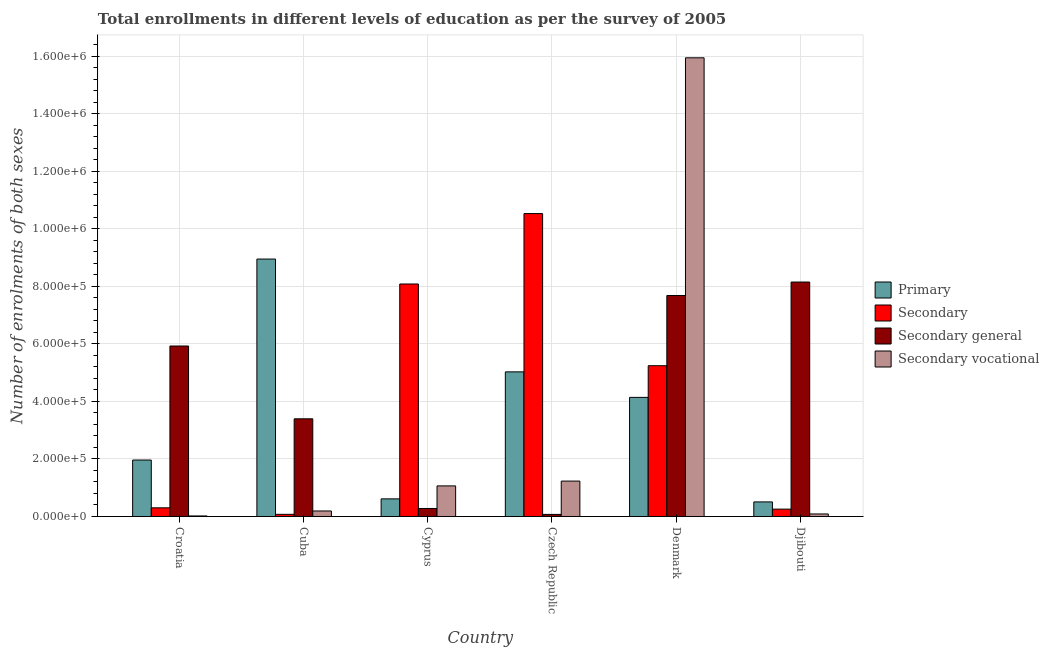How many groups of bars are there?
Your answer should be compact. 6. Are the number of bars per tick equal to the number of legend labels?
Your response must be concise. Yes. Are the number of bars on each tick of the X-axis equal?
Offer a very short reply. Yes. How many bars are there on the 2nd tick from the left?
Your response must be concise. 4. What is the number of enrolments in secondary general education in Croatia?
Provide a short and direct response. 5.93e+05. Across all countries, what is the maximum number of enrolments in secondary general education?
Your response must be concise. 8.15e+05. Across all countries, what is the minimum number of enrolments in secondary education?
Make the answer very short. 7476. In which country was the number of enrolments in secondary general education maximum?
Your answer should be very brief. Djibouti. In which country was the number of enrolments in secondary education minimum?
Make the answer very short. Cuba. What is the total number of enrolments in secondary vocational education in the graph?
Provide a succinct answer. 1.85e+06. What is the difference between the number of enrolments in secondary education in Cuba and that in Djibouti?
Your answer should be compact. -1.81e+04. What is the difference between the number of enrolments in secondary vocational education in Cuba and the number of enrolments in primary education in Cyprus?
Provide a succinct answer. -4.21e+04. What is the average number of enrolments in secondary general education per country?
Give a very brief answer. 4.25e+05. What is the difference between the number of enrolments in secondary vocational education and number of enrolments in secondary education in Denmark?
Offer a very short reply. 1.07e+06. In how many countries, is the number of enrolments in secondary general education greater than 1360000 ?
Give a very brief answer. 0. What is the ratio of the number of enrolments in secondary vocational education in Croatia to that in Cuba?
Provide a short and direct response. 0.1. Is the difference between the number of enrolments in secondary education in Cuba and Denmark greater than the difference between the number of enrolments in secondary general education in Cuba and Denmark?
Your response must be concise. No. What is the difference between the highest and the second highest number of enrolments in secondary general education?
Your answer should be very brief. 4.68e+04. What is the difference between the highest and the lowest number of enrolments in secondary vocational education?
Ensure brevity in your answer.  1.59e+06. What does the 3rd bar from the left in Cyprus represents?
Give a very brief answer. Secondary general. What does the 3rd bar from the right in Denmark represents?
Provide a succinct answer. Secondary. Is it the case that in every country, the sum of the number of enrolments in primary education and number of enrolments in secondary education is greater than the number of enrolments in secondary general education?
Provide a short and direct response. No. How many bars are there?
Ensure brevity in your answer.  24. How many countries are there in the graph?
Give a very brief answer. 6. Are the values on the major ticks of Y-axis written in scientific E-notation?
Provide a short and direct response. Yes. How many legend labels are there?
Provide a short and direct response. 4. What is the title of the graph?
Make the answer very short. Total enrollments in different levels of education as per the survey of 2005. Does "Others" appear as one of the legend labels in the graph?
Give a very brief answer. No. What is the label or title of the Y-axis?
Offer a very short reply. Number of enrolments of both sexes. What is the Number of enrolments of both sexes of Primary in Croatia?
Make the answer very short. 1.96e+05. What is the Number of enrolments of both sexes of Secondary in Croatia?
Your answer should be very brief. 3.01e+04. What is the Number of enrolments of both sexes of Secondary general in Croatia?
Your answer should be very brief. 5.93e+05. What is the Number of enrolments of both sexes in Secondary vocational in Croatia?
Make the answer very short. 1864. What is the Number of enrolments of both sexes in Primary in Cuba?
Give a very brief answer. 8.95e+05. What is the Number of enrolments of both sexes of Secondary in Cuba?
Provide a succinct answer. 7476. What is the Number of enrolments of both sexes in Secondary general in Cuba?
Your response must be concise. 3.40e+05. What is the Number of enrolments of both sexes of Secondary vocational in Cuba?
Your response must be concise. 1.92e+04. What is the Number of enrolments of both sexes in Primary in Cyprus?
Your response must be concise. 6.12e+04. What is the Number of enrolments of both sexes in Secondary in Cyprus?
Your answer should be compact. 8.08e+05. What is the Number of enrolments of both sexes in Secondary general in Cyprus?
Offer a very short reply. 2.78e+04. What is the Number of enrolments of both sexes in Secondary vocational in Cyprus?
Ensure brevity in your answer.  1.06e+05. What is the Number of enrolments of both sexes in Primary in Czech Republic?
Ensure brevity in your answer.  5.03e+05. What is the Number of enrolments of both sexes in Secondary in Czech Republic?
Your response must be concise. 1.05e+06. What is the Number of enrolments of both sexes in Secondary general in Czech Republic?
Ensure brevity in your answer.  7218. What is the Number of enrolments of both sexes of Secondary vocational in Czech Republic?
Your answer should be very brief. 1.23e+05. What is the Number of enrolments of both sexes of Primary in Denmark?
Ensure brevity in your answer.  4.14e+05. What is the Number of enrolments of both sexes in Secondary in Denmark?
Ensure brevity in your answer.  5.24e+05. What is the Number of enrolments of both sexes in Secondary general in Denmark?
Your response must be concise. 7.68e+05. What is the Number of enrolments of both sexes of Secondary vocational in Denmark?
Keep it short and to the point. 1.59e+06. What is the Number of enrolments of both sexes of Primary in Djibouti?
Keep it short and to the point. 5.07e+04. What is the Number of enrolments of both sexes of Secondary in Djibouti?
Provide a short and direct response. 2.55e+04. What is the Number of enrolments of both sexes in Secondary general in Djibouti?
Make the answer very short. 8.15e+05. What is the Number of enrolments of both sexes of Secondary vocational in Djibouti?
Keep it short and to the point. 8777. Across all countries, what is the maximum Number of enrolments of both sexes of Primary?
Your response must be concise. 8.95e+05. Across all countries, what is the maximum Number of enrolments of both sexes of Secondary?
Ensure brevity in your answer.  1.05e+06. Across all countries, what is the maximum Number of enrolments of both sexes of Secondary general?
Make the answer very short. 8.15e+05. Across all countries, what is the maximum Number of enrolments of both sexes of Secondary vocational?
Give a very brief answer. 1.59e+06. Across all countries, what is the minimum Number of enrolments of both sexes in Primary?
Offer a very short reply. 5.07e+04. Across all countries, what is the minimum Number of enrolments of both sexes of Secondary?
Keep it short and to the point. 7476. Across all countries, what is the minimum Number of enrolments of both sexes in Secondary general?
Your answer should be very brief. 7218. Across all countries, what is the minimum Number of enrolments of both sexes of Secondary vocational?
Your answer should be compact. 1864. What is the total Number of enrolments of both sexes in Primary in the graph?
Ensure brevity in your answer.  2.12e+06. What is the total Number of enrolments of both sexes in Secondary in the graph?
Your answer should be compact. 2.45e+06. What is the total Number of enrolments of both sexes in Secondary general in the graph?
Make the answer very short. 2.55e+06. What is the total Number of enrolments of both sexes in Secondary vocational in the graph?
Your answer should be very brief. 1.85e+06. What is the difference between the Number of enrolments of both sexes of Primary in Croatia and that in Cuba?
Keep it short and to the point. -6.99e+05. What is the difference between the Number of enrolments of both sexes of Secondary in Croatia and that in Cuba?
Your response must be concise. 2.27e+04. What is the difference between the Number of enrolments of both sexes in Secondary general in Croatia and that in Cuba?
Your response must be concise. 2.53e+05. What is the difference between the Number of enrolments of both sexes of Secondary vocational in Croatia and that in Cuba?
Provide a short and direct response. -1.73e+04. What is the difference between the Number of enrolments of both sexes in Primary in Croatia and that in Cyprus?
Your answer should be very brief. 1.35e+05. What is the difference between the Number of enrolments of both sexes in Secondary in Croatia and that in Cyprus?
Give a very brief answer. -7.78e+05. What is the difference between the Number of enrolments of both sexes of Secondary general in Croatia and that in Cyprus?
Ensure brevity in your answer.  5.65e+05. What is the difference between the Number of enrolments of both sexes in Secondary vocational in Croatia and that in Cyprus?
Give a very brief answer. -1.04e+05. What is the difference between the Number of enrolments of both sexes in Primary in Croatia and that in Czech Republic?
Offer a very short reply. -3.07e+05. What is the difference between the Number of enrolments of both sexes of Secondary in Croatia and that in Czech Republic?
Keep it short and to the point. -1.02e+06. What is the difference between the Number of enrolments of both sexes of Secondary general in Croatia and that in Czech Republic?
Your response must be concise. 5.85e+05. What is the difference between the Number of enrolments of both sexes of Secondary vocational in Croatia and that in Czech Republic?
Ensure brevity in your answer.  -1.21e+05. What is the difference between the Number of enrolments of both sexes in Primary in Croatia and that in Denmark?
Offer a very short reply. -2.18e+05. What is the difference between the Number of enrolments of both sexes of Secondary in Croatia and that in Denmark?
Your answer should be compact. -4.94e+05. What is the difference between the Number of enrolments of both sexes in Secondary general in Croatia and that in Denmark?
Ensure brevity in your answer.  -1.76e+05. What is the difference between the Number of enrolments of both sexes in Secondary vocational in Croatia and that in Denmark?
Provide a succinct answer. -1.59e+06. What is the difference between the Number of enrolments of both sexes in Primary in Croatia and that in Djibouti?
Make the answer very short. 1.46e+05. What is the difference between the Number of enrolments of both sexes of Secondary in Croatia and that in Djibouti?
Make the answer very short. 4598. What is the difference between the Number of enrolments of both sexes of Secondary general in Croatia and that in Djibouti?
Your response must be concise. -2.22e+05. What is the difference between the Number of enrolments of both sexes in Secondary vocational in Croatia and that in Djibouti?
Make the answer very short. -6913. What is the difference between the Number of enrolments of both sexes of Primary in Cuba and that in Cyprus?
Make the answer very short. 8.34e+05. What is the difference between the Number of enrolments of both sexes in Secondary in Cuba and that in Cyprus?
Offer a very short reply. -8.01e+05. What is the difference between the Number of enrolments of both sexes of Secondary general in Cuba and that in Cyprus?
Make the answer very short. 3.12e+05. What is the difference between the Number of enrolments of both sexes in Secondary vocational in Cuba and that in Cyprus?
Your answer should be compact. -8.72e+04. What is the difference between the Number of enrolments of both sexes of Primary in Cuba and that in Czech Republic?
Provide a short and direct response. 3.92e+05. What is the difference between the Number of enrolments of both sexes of Secondary in Cuba and that in Czech Republic?
Ensure brevity in your answer.  -1.05e+06. What is the difference between the Number of enrolments of both sexes of Secondary general in Cuba and that in Czech Republic?
Make the answer very short. 3.32e+05. What is the difference between the Number of enrolments of both sexes of Secondary vocational in Cuba and that in Czech Republic?
Offer a terse response. -1.04e+05. What is the difference between the Number of enrolments of both sexes in Primary in Cuba and that in Denmark?
Keep it short and to the point. 4.81e+05. What is the difference between the Number of enrolments of both sexes of Secondary in Cuba and that in Denmark?
Provide a short and direct response. -5.17e+05. What is the difference between the Number of enrolments of both sexes of Secondary general in Cuba and that in Denmark?
Your answer should be compact. -4.29e+05. What is the difference between the Number of enrolments of both sexes of Secondary vocational in Cuba and that in Denmark?
Your response must be concise. -1.58e+06. What is the difference between the Number of enrolments of both sexes in Primary in Cuba and that in Djibouti?
Your response must be concise. 8.44e+05. What is the difference between the Number of enrolments of both sexes of Secondary in Cuba and that in Djibouti?
Your answer should be compact. -1.81e+04. What is the difference between the Number of enrolments of both sexes in Secondary general in Cuba and that in Djibouti?
Offer a very short reply. -4.76e+05. What is the difference between the Number of enrolments of both sexes in Secondary vocational in Cuba and that in Djibouti?
Ensure brevity in your answer.  1.04e+04. What is the difference between the Number of enrolments of both sexes in Primary in Cyprus and that in Czech Republic?
Offer a very short reply. -4.42e+05. What is the difference between the Number of enrolments of both sexes in Secondary in Cyprus and that in Czech Republic?
Provide a short and direct response. -2.45e+05. What is the difference between the Number of enrolments of both sexes of Secondary general in Cyprus and that in Czech Republic?
Keep it short and to the point. 2.06e+04. What is the difference between the Number of enrolments of both sexes in Secondary vocational in Cyprus and that in Czech Republic?
Offer a terse response. -1.68e+04. What is the difference between the Number of enrolments of both sexes in Primary in Cyprus and that in Denmark?
Your answer should be compact. -3.53e+05. What is the difference between the Number of enrolments of both sexes of Secondary in Cyprus and that in Denmark?
Keep it short and to the point. 2.84e+05. What is the difference between the Number of enrolments of both sexes of Secondary general in Cyprus and that in Denmark?
Offer a very short reply. -7.41e+05. What is the difference between the Number of enrolments of both sexes of Secondary vocational in Cyprus and that in Denmark?
Keep it short and to the point. -1.49e+06. What is the difference between the Number of enrolments of both sexes in Primary in Cyprus and that in Djibouti?
Provide a short and direct response. 1.06e+04. What is the difference between the Number of enrolments of both sexes of Secondary in Cyprus and that in Djibouti?
Offer a very short reply. 7.83e+05. What is the difference between the Number of enrolments of both sexes in Secondary general in Cyprus and that in Djibouti?
Your response must be concise. -7.87e+05. What is the difference between the Number of enrolments of both sexes of Secondary vocational in Cyprus and that in Djibouti?
Provide a succinct answer. 9.76e+04. What is the difference between the Number of enrolments of both sexes in Primary in Czech Republic and that in Denmark?
Offer a terse response. 8.87e+04. What is the difference between the Number of enrolments of both sexes of Secondary in Czech Republic and that in Denmark?
Give a very brief answer. 5.29e+05. What is the difference between the Number of enrolments of both sexes in Secondary general in Czech Republic and that in Denmark?
Ensure brevity in your answer.  -7.61e+05. What is the difference between the Number of enrolments of both sexes of Secondary vocational in Czech Republic and that in Denmark?
Keep it short and to the point. -1.47e+06. What is the difference between the Number of enrolments of both sexes in Primary in Czech Republic and that in Djibouti?
Ensure brevity in your answer.  4.52e+05. What is the difference between the Number of enrolments of both sexes of Secondary in Czech Republic and that in Djibouti?
Your answer should be very brief. 1.03e+06. What is the difference between the Number of enrolments of both sexes in Secondary general in Czech Republic and that in Djibouti?
Provide a short and direct response. -8.08e+05. What is the difference between the Number of enrolments of both sexes in Secondary vocational in Czech Republic and that in Djibouti?
Make the answer very short. 1.14e+05. What is the difference between the Number of enrolments of both sexes of Primary in Denmark and that in Djibouti?
Provide a succinct answer. 3.63e+05. What is the difference between the Number of enrolments of both sexes of Secondary in Denmark and that in Djibouti?
Offer a very short reply. 4.99e+05. What is the difference between the Number of enrolments of both sexes of Secondary general in Denmark and that in Djibouti?
Keep it short and to the point. -4.68e+04. What is the difference between the Number of enrolments of both sexes of Secondary vocational in Denmark and that in Djibouti?
Your answer should be very brief. 1.59e+06. What is the difference between the Number of enrolments of both sexes of Primary in Croatia and the Number of enrolments of both sexes of Secondary in Cuba?
Provide a short and direct response. 1.89e+05. What is the difference between the Number of enrolments of both sexes of Primary in Croatia and the Number of enrolments of both sexes of Secondary general in Cuba?
Your response must be concise. -1.43e+05. What is the difference between the Number of enrolments of both sexes in Primary in Croatia and the Number of enrolments of both sexes in Secondary vocational in Cuba?
Your response must be concise. 1.77e+05. What is the difference between the Number of enrolments of both sexes in Secondary in Croatia and the Number of enrolments of both sexes in Secondary general in Cuba?
Your answer should be compact. -3.09e+05. What is the difference between the Number of enrolments of both sexes in Secondary in Croatia and the Number of enrolments of both sexes in Secondary vocational in Cuba?
Offer a very short reply. 1.10e+04. What is the difference between the Number of enrolments of both sexes of Secondary general in Croatia and the Number of enrolments of both sexes of Secondary vocational in Cuba?
Give a very brief answer. 5.74e+05. What is the difference between the Number of enrolments of both sexes of Primary in Croatia and the Number of enrolments of both sexes of Secondary in Cyprus?
Provide a succinct answer. -6.12e+05. What is the difference between the Number of enrolments of both sexes in Primary in Croatia and the Number of enrolments of both sexes in Secondary general in Cyprus?
Offer a terse response. 1.68e+05. What is the difference between the Number of enrolments of both sexes of Primary in Croatia and the Number of enrolments of both sexes of Secondary vocational in Cyprus?
Give a very brief answer. 8.99e+04. What is the difference between the Number of enrolments of both sexes of Secondary in Croatia and the Number of enrolments of both sexes of Secondary general in Cyprus?
Keep it short and to the point. 2321. What is the difference between the Number of enrolments of both sexes in Secondary in Croatia and the Number of enrolments of both sexes in Secondary vocational in Cyprus?
Provide a short and direct response. -7.62e+04. What is the difference between the Number of enrolments of both sexes of Secondary general in Croatia and the Number of enrolments of both sexes of Secondary vocational in Cyprus?
Your answer should be compact. 4.86e+05. What is the difference between the Number of enrolments of both sexes in Primary in Croatia and the Number of enrolments of both sexes in Secondary in Czech Republic?
Make the answer very short. -8.57e+05. What is the difference between the Number of enrolments of both sexes in Primary in Croatia and the Number of enrolments of both sexes in Secondary general in Czech Republic?
Provide a short and direct response. 1.89e+05. What is the difference between the Number of enrolments of both sexes of Primary in Croatia and the Number of enrolments of both sexes of Secondary vocational in Czech Republic?
Offer a very short reply. 7.31e+04. What is the difference between the Number of enrolments of both sexes of Secondary in Croatia and the Number of enrolments of both sexes of Secondary general in Czech Republic?
Offer a terse response. 2.29e+04. What is the difference between the Number of enrolments of both sexes in Secondary in Croatia and the Number of enrolments of both sexes in Secondary vocational in Czech Republic?
Keep it short and to the point. -9.30e+04. What is the difference between the Number of enrolments of both sexes of Secondary general in Croatia and the Number of enrolments of both sexes of Secondary vocational in Czech Republic?
Your response must be concise. 4.70e+05. What is the difference between the Number of enrolments of both sexes of Primary in Croatia and the Number of enrolments of both sexes of Secondary in Denmark?
Give a very brief answer. -3.28e+05. What is the difference between the Number of enrolments of both sexes in Primary in Croatia and the Number of enrolments of both sexes in Secondary general in Denmark?
Provide a succinct answer. -5.72e+05. What is the difference between the Number of enrolments of both sexes in Primary in Croatia and the Number of enrolments of both sexes in Secondary vocational in Denmark?
Offer a terse response. -1.40e+06. What is the difference between the Number of enrolments of both sexes of Secondary in Croatia and the Number of enrolments of both sexes of Secondary general in Denmark?
Provide a short and direct response. -7.38e+05. What is the difference between the Number of enrolments of both sexes in Secondary in Croatia and the Number of enrolments of both sexes in Secondary vocational in Denmark?
Give a very brief answer. -1.56e+06. What is the difference between the Number of enrolments of both sexes in Secondary general in Croatia and the Number of enrolments of both sexes in Secondary vocational in Denmark?
Your answer should be very brief. -1.00e+06. What is the difference between the Number of enrolments of both sexes in Primary in Croatia and the Number of enrolments of both sexes in Secondary in Djibouti?
Provide a short and direct response. 1.71e+05. What is the difference between the Number of enrolments of both sexes in Primary in Croatia and the Number of enrolments of both sexes in Secondary general in Djibouti?
Your answer should be very brief. -6.19e+05. What is the difference between the Number of enrolments of both sexes of Primary in Croatia and the Number of enrolments of both sexes of Secondary vocational in Djibouti?
Provide a succinct answer. 1.87e+05. What is the difference between the Number of enrolments of both sexes of Secondary in Croatia and the Number of enrolments of both sexes of Secondary general in Djibouti?
Your response must be concise. -7.85e+05. What is the difference between the Number of enrolments of both sexes in Secondary in Croatia and the Number of enrolments of both sexes in Secondary vocational in Djibouti?
Offer a terse response. 2.14e+04. What is the difference between the Number of enrolments of both sexes in Secondary general in Croatia and the Number of enrolments of both sexes in Secondary vocational in Djibouti?
Give a very brief answer. 5.84e+05. What is the difference between the Number of enrolments of both sexes of Primary in Cuba and the Number of enrolments of both sexes of Secondary in Cyprus?
Your answer should be compact. 8.67e+04. What is the difference between the Number of enrolments of both sexes of Primary in Cuba and the Number of enrolments of both sexes of Secondary general in Cyprus?
Your answer should be very brief. 8.67e+05. What is the difference between the Number of enrolments of both sexes of Primary in Cuba and the Number of enrolments of both sexes of Secondary vocational in Cyprus?
Provide a short and direct response. 7.89e+05. What is the difference between the Number of enrolments of both sexes in Secondary in Cuba and the Number of enrolments of both sexes in Secondary general in Cyprus?
Offer a very short reply. -2.03e+04. What is the difference between the Number of enrolments of both sexes of Secondary in Cuba and the Number of enrolments of both sexes of Secondary vocational in Cyprus?
Make the answer very short. -9.89e+04. What is the difference between the Number of enrolments of both sexes in Secondary general in Cuba and the Number of enrolments of both sexes in Secondary vocational in Cyprus?
Offer a terse response. 2.33e+05. What is the difference between the Number of enrolments of both sexes in Primary in Cuba and the Number of enrolments of both sexes in Secondary in Czech Republic?
Provide a succinct answer. -1.58e+05. What is the difference between the Number of enrolments of both sexes of Primary in Cuba and the Number of enrolments of both sexes of Secondary general in Czech Republic?
Offer a very short reply. 8.88e+05. What is the difference between the Number of enrolments of both sexes in Primary in Cuba and the Number of enrolments of both sexes in Secondary vocational in Czech Republic?
Give a very brief answer. 7.72e+05. What is the difference between the Number of enrolments of both sexes of Secondary in Cuba and the Number of enrolments of both sexes of Secondary general in Czech Republic?
Your answer should be compact. 258. What is the difference between the Number of enrolments of both sexes in Secondary in Cuba and the Number of enrolments of both sexes in Secondary vocational in Czech Republic?
Your response must be concise. -1.16e+05. What is the difference between the Number of enrolments of both sexes of Secondary general in Cuba and the Number of enrolments of both sexes of Secondary vocational in Czech Republic?
Provide a succinct answer. 2.16e+05. What is the difference between the Number of enrolments of both sexes in Primary in Cuba and the Number of enrolments of both sexes in Secondary in Denmark?
Offer a terse response. 3.71e+05. What is the difference between the Number of enrolments of both sexes in Primary in Cuba and the Number of enrolments of both sexes in Secondary general in Denmark?
Offer a terse response. 1.27e+05. What is the difference between the Number of enrolments of both sexes in Primary in Cuba and the Number of enrolments of both sexes in Secondary vocational in Denmark?
Ensure brevity in your answer.  -7.00e+05. What is the difference between the Number of enrolments of both sexes in Secondary in Cuba and the Number of enrolments of both sexes in Secondary general in Denmark?
Make the answer very short. -7.61e+05. What is the difference between the Number of enrolments of both sexes of Secondary in Cuba and the Number of enrolments of both sexes of Secondary vocational in Denmark?
Ensure brevity in your answer.  -1.59e+06. What is the difference between the Number of enrolments of both sexes of Secondary general in Cuba and the Number of enrolments of both sexes of Secondary vocational in Denmark?
Offer a very short reply. -1.26e+06. What is the difference between the Number of enrolments of both sexes in Primary in Cuba and the Number of enrolments of both sexes in Secondary in Djibouti?
Your answer should be very brief. 8.70e+05. What is the difference between the Number of enrolments of both sexes in Primary in Cuba and the Number of enrolments of both sexes in Secondary general in Djibouti?
Offer a terse response. 7.99e+04. What is the difference between the Number of enrolments of both sexes of Primary in Cuba and the Number of enrolments of both sexes of Secondary vocational in Djibouti?
Keep it short and to the point. 8.86e+05. What is the difference between the Number of enrolments of both sexes of Secondary in Cuba and the Number of enrolments of both sexes of Secondary general in Djibouti?
Provide a short and direct response. -8.08e+05. What is the difference between the Number of enrolments of both sexes in Secondary in Cuba and the Number of enrolments of both sexes in Secondary vocational in Djibouti?
Your answer should be compact. -1301. What is the difference between the Number of enrolments of both sexes in Secondary general in Cuba and the Number of enrolments of both sexes in Secondary vocational in Djibouti?
Your answer should be compact. 3.31e+05. What is the difference between the Number of enrolments of both sexes in Primary in Cyprus and the Number of enrolments of both sexes in Secondary in Czech Republic?
Offer a very short reply. -9.92e+05. What is the difference between the Number of enrolments of both sexes in Primary in Cyprus and the Number of enrolments of both sexes in Secondary general in Czech Republic?
Your answer should be compact. 5.40e+04. What is the difference between the Number of enrolments of both sexes in Primary in Cyprus and the Number of enrolments of both sexes in Secondary vocational in Czech Republic?
Keep it short and to the point. -6.19e+04. What is the difference between the Number of enrolments of both sexes in Secondary in Cyprus and the Number of enrolments of both sexes in Secondary general in Czech Republic?
Your response must be concise. 8.01e+05. What is the difference between the Number of enrolments of both sexes in Secondary in Cyprus and the Number of enrolments of both sexes in Secondary vocational in Czech Republic?
Provide a short and direct response. 6.85e+05. What is the difference between the Number of enrolments of both sexes in Secondary general in Cyprus and the Number of enrolments of both sexes in Secondary vocational in Czech Republic?
Keep it short and to the point. -9.53e+04. What is the difference between the Number of enrolments of both sexes in Primary in Cyprus and the Number of enrolments of both sexes in Secondary in Denmark?
Provide a short and direct response. -4.63e+05. What is the difference between the Number of enrolments of both sexes in Primary in Cyprus and the Number of enrolments of both sexes in Secondary general in Denmark?
Ensure brevity in your answer.  -7.07e+05. What is the difference between the Number of enrolments of both sexes of Primary in Cyprus and the Number of enrolments of both sexes of Secondary vocational in Denmark?
Ensure brevity in your answer.  -1.53e+06. What is the difference between the Number of enrolments of both sexes of Secondary in Cyprus and the Number of enrolments of both sexes of Secondary general in Denmark?
Provide a short and direct response. 4.00e+04. What is the difference between the Number of enrolments of both sexes in Secondary in Cyprus and the Number of enrolments of both sexes in Secondary vocational in Denmark?
Offer a terse response. -7.86e+05. What is the difference between the Number of enrolments of both sexes in Secondary general in Cyprus and the Number of enrolments of both sexes in Secondary vocational in Denmark?
Provide a short and direct response. -1.57e+06. What is the difference between the Number of enrolments of both sexes in Primary in Cyprus and the Number of enrolments of both sexes in Secondary in Djibouti?
Your response must be concise. 3.57e+04. What is the difference between the Number of enrolments of both sexes in Primary in Cyprus and the Number of enrolments of both sexes in Secondary general in Djibouti?
Provide a succinct answer. -7.54e+05. What is the difference between the Number of enrolments of both sexes of Primary in Cyprus and the Number of enrolments of both sexes of Secondary vocational in Djibouti?
Provide a succinct answer. 5.25e+04. What is the difference between the Number of enrolments of both sexes of Secondary in Cyprus and the Number of enrolments of both sexes of Secondary general in Djibouti?
Make the answer very short. -6760. What is the difference between the Number of enrolments of both sexes in Secondary in Cyprus and the Number of enrolments of both sexes in Secondary vocational in Djibouti?
Your answer should be very brief. 8.00e+05. What is the difference between the Number of enrolments of both sexes in Secondary general in Cyprus and the Number of enrolments of both sexes in Secondary vocational in Djibouti?
Your answer should be very brief. 1.90e+04. What is the difference between the Number of enrolments of both sexes of Primary in Czech Republic and the Number of enrolments of both sexes of Secondary in Denmark?
Provide a succinct answer. -2.14e+04. What is the difference between the Number of enrolments of both sexes in Primary in Czech Republic and the Number of enrolments of both sexes in Secondary general in Denmark?
Ensure brevity in your answer.  -2.66e+05. What is the difference between the Number of enrolments of both sexes in Primary in Czech Republic and the Number of enrolments of both sexes in Secondary vocational in Denmark?
Your answer should be very brief. -1.09e+06. What is the difference between the Number of enrolments of both sexes in Secondary in Czech Republic and the Number of enrolments of both sexes in Secondary general in Denmark?
Offer a terse response. 2.85e+05. What is the difference between the Number of enrolments of both sexes of Secondary in Czech Republic and the Number of enrolments of both sexes of Secondary vocational in Denmark?
Offer a terse response. -5.42e+05. What is the difference between the Number of enrolments of both sexes of Secondary general in Czech Republic and the Number of enrolments of both sexes of Secondary vocational in Denmark?
Offer a very short reply. -1.59e+06. What is the difference between the Number of enrolments of both sexes of Primary in Czech Republic and the Number of enrolments of both sexes of Secondary in Djibouti?
Keep it short and to the point. 4.77e+05. What is the difference between the Number of enrolments of both sexes of Primary in Czech Republic and the Number of enrolments of both sexes of Secondary general in Djibouti?
Ensure brevity in your answer.  -3.12e+05. What is the difference between the Number of enrolments of both sexes in Primary in Czech Republic and the Number of enrolments of both sexes in Secondary vocational in Djibouti?
Provide a succinct answer. 4.94e+05. What is the difference between the Number of enrolments of both sexes in Secondary in Czech Republic and the Number of enrolments of both sexes in Secondary general in Djibouti?
Keep it short and to the point. 2.38e+05. What is the difference between the Number of enrolments of both sexes in Secondary in Czech Republic and the Number of enrolments of both sexes in Secondary vocational in Djibouti?
Give a very brief answer. 1.04e+06. What is the difference between the Number of enrolments of both sexes of Secondary general in Czech Republic and the Number of enrolments of both sexes of Secondary vocational in Djibouti?
Provide a short and direct response. -1559. What is the difference between the Number of enrolments of both sexes of Primary in Denmark and the Number of enrolments of both sexes of Secondary in Djibouti?
Make the answer very short. 3.89e+05. What is the difference between the Number of enrolments of both sexes in Primary in Denmark and the Number of enrolments of both sexes in Secondary general in Djibouti?
Give a very brief answer. -4.01e+05. What is the difference between the Number of enrolments of both sexes of Primary in Denmark and the Number of enrolments of both sexes of Secondary vocational in Djibouti?
Ensure brevity in your answer.  4.05e+05. What is the difference between the Number of enrolments of both sexes of Secondary in Denmark and the Number of enrolments of both sexes of Secondary general in Djibouti?
Your answer should be compact. -2.91e+05. What is the difference between the Number of enrolments of both sexes of Secondary in Denmark and the Number of enrolments of both sexes of Secondary vocational in Djibouti?
Your answer should be very brief. 5.15e+05. What is the difference between the Number of enrolments of both sexes in Secondary general in Denmark and the Number of enrolments of both sexes in Secondary vocational in Djibouti?
Make the answer very short. 7.60e+05. What is the average Number of enrolments of both sexes of Primary per country?
Make the answer very short. 3.53e+05. What is the average Number of enrolments of both sexes of Secondary per country?
Your response must be concise. 4.08e+05. What is the average Number of enrolments of both sexes in Secondary general per country?
Your answer should be very brief. 4.25e+05. What is the average Number of enrolments of both sexes in Secondary vocational per country?
Offer a very short reply. 3.09e+05. What is the difference between the Number of enrolments of both sexes in Primary and Number of enrolments of both sexes in Secondary in Croatia?
Offer a very short reply. 1.66e+05. What is the difference between the Number of enrolments of both sexes of Primary and Number of enrolments of both sexes of Secondary general in Croatia?
Offer a very short reply. -3.96e+05. What is the difference between the Number of enrolments of both sexes in Primary and Number of enrolments of both sexes in Secondary vocational in Croatia?
Offer a very short reply. 1.94e+05. What is the difference between the Number of enrolments of both sexes of Secondary and Number of enrolments of both sexes of Secondary general in Croatia?
Ensure brevity in your answer.  -5.63e+05. What is the difference between the Number of enrolments of both sexes of Secondary and Number of enrolments of both sexes of Secondary vocational in Croatia?
Ensure brevity in your answer.  2.83e+04. What is the difference between the Number of enrolments of both sexes of Secondary general and Number of enrolments of both sexes of Secondary vocational in Croatia?
Your answer should be very brief. 5.91e+05. What is the difference between the Number of enrolments of both sexes of Primary and Number of enrolments of both sexes of Secondary in Cuba?
Ensure brevity in your answer.  8.88e+05. What is the difference between the Number of enrolments of both sexes in Primary and Number of enrolments of both sexes in Secondary general in Cuba?
Your response must be concise. 5.55e+05. What is the difference between the Number of enrolments of both sexes in Primary and Number of enrolments of both sexes in Secondary vocational in Cuba?
Offer a very short reply. 8.76e+05. What is the difference between the Number of enrolments of both sexes of Secondary and Number of enrolments of both sexes of Secondary general in Cuba?
Provide a short and direct response. -3.32e+05. What is the difference between the Number of enrolments of both sexes in Secondary and Number of enrolments of both sexes in Secondary vocational in Cuba?
Your answer should be compact. -1.17e+04. What is the difference between the Number of enrolments of both sexes of Secondary general and Number of enrolments of both sexes of Secondary vocational in Cuba?
Provide a succinct answer. 3.20e+05. What is the difference between the Number of enrolments of both sexes of Primary and Number of enrolments of both sexes of Secondary in Cyprus?
Keep it short and to the point. -7.47e+05. What is the difference between the Number of enrolments of both sexes in Primary and Number of enrolments of both sexes in Secondary general in Cyprus?
Offer a very short reply. 3.34e+04. What is the difference between the Number of enrolments of both sexes in Primary and Number of enrolments of both sexes in Secondary vocational in Cyprus?
Offer a terse response. -4.51e+04. What is the difference between the Number of enrolments of both sexes of Secondary and Number of enrolments of both sexes of Secondary general in Cyprus?
Your response must be concise. 7.81e+05. What is the difference between the Number of enrolments of both sexes of Secondary and Number of enrolments of both sexes of Secondary vocational in Cyprus?
Offer a very short reply. 7.02e+05. What is the difference between the Number of enrolments of both sexes of Secondary general and Number of enrolments of both sexes of Secondary vocational in Cyprus?
Your answer should be very brief. -7.85e+04. What is the difference between the Number of enrolments of both sexes of Primary and Number of enrolments of both sexes of Secondary in Czech Republic?
Keep it short and to the point. -5.50e+05. What is the difference between the Number of enrolments of both sexes in Primary and Number of enrolments of both sexes in Secondary general in Czech Republic?
Make the answer very short. 4.96e+05. What is the difference between the Number of enrolments of both sexes in Primary and Number of enrolments of both sexes in Secondary vocational in Czech Republic?
Your answer should be very brief. 3.80e+05. What is the difference between the Number of enrolments of both sexes of Secondary and Number of enrolments of both sexes of Secondary general in Czech Republic?
Make the answer very short. 1.05e+06. What is the difference between the Number of enrolments of both sexes in Secondary and Number of enrolments of both sexes in Secondary vocational in Czech Republic?
Provide a succinct answer. 9.30e+05. What is the difference between the Number of enrolments of both sexes in Secondary general and Number of enrolments of both sexes in Secondary vocational in Czech Republic?
Provide a succinct answer. -1.16e+05. What is the difference between the Number of enrolments of both sexes in Primary and Number of enrolments of both sexes in Secondary in Denmark?
Offer a very short reply. -1.10e+05. What is the difference between the Number of enrolments of both sexes of Primary and Number of enrolments of both sexes of Secondary general in Denmark?
Make the answer very short. -3.54e+05. What is the difference between the Number of enrolments of both sexes in Primary and Number of enrolments of both sexes in Secondary vocational in Denmark?
Ensure brevity in your answer.  -1.18e+06. What is the difference between the Number of enrolments of both sexes in Secondary and Number of enrolments of both sexes in Secondary general in Denmark?
Your response must be concise. -2.44e+05. What is the difference between the Number of enrolments of both sexes in Secondary and Number of enrolments of both sexes in Secondary vocational in Denmark?
Your answer should be compact. -1.07e+06. What is the difference between the Number of enrolments of both sexes in Secondary general and Number of enrolments of both sexes in Secondary vocational in Denmark?
Your response must be concise. -8.26e+05. What is the difference between the Number of enrolments of both sexes in Primary and Number of enrolments of both sexes in Secondary in Djibouti?
Your response must be concise. 2.51e+04. What is the difference between the Number of enrolments of both sexes in Primary and Number of enrolments of both sexes in Secondary general in Djibouti?
Provide a short and direct response. -7.64e+05. What is the difference between the Number of enrolments of both sexes of Primary and Number of enrolments of both sexes of Secondary vocational in Djibouti?
Your answer should be very brief. 4.19e+04. What is the difference between the Number of enrolments of both sexes of Secondary and Number of enrolments of both sexes of Secondary general in Djibouti?
Give a very brief answer. -7.90e+05. What is the difference between the Number of enrolments of both sexes of Secondary and Number of enrolments of both sexes of Secondary vocational in Djibouti?
Offer a very short reply. 1.68e+04. What is the difference between the Number of enrolments of both sexes in Secondary general and Number of enrolments of both sexes in Secondary vocational in Djibouti?
Provide a succinct answer. 8.06e+05. What is the ratio of the Number of enrolments of both sexes of Primary in Croatia to that in Cuba?
Provide a short and direct response. 0.22. What is the ratio of the Number of enrolments of both sexes in Secondary in Croatia to that in Cuba?
Your response must be concise. 4.03. What is the ratio of the Number of enrolments of both sexes of Secondary general in Croatia to that in Cuba?
Your response must be concise. 1.75. What is the ratio of the Number of enrolments of both sexes in Secondary vocational in Croatia to that in Cuba?
Your answer should be very brief. 0.1. What is the ratio of the Number of enrolments of both sexes of Primary in Croatia to that in Cyprus?
Your answer should be very brief. 3.2. What is the ratio of the Number of enrolments of both sexes of Secondary in Croatia to that in Cyprus?
Make the answer very short. 0.04. What is the ratio of the Number of enrolments of both sexes of Secondary general in Croatia to that in Cyprus?
Provide a succinct answer. 21.3. What is the ratio of the Number of enrolments of both sexes of Secondary vocational in Croatia to that in Cyprus?
Offer a very short reply. 0.02. What is the ratio of the Number of enrolments of both sexes in Primary in Croatia to that in Czech Republic?
Your answer should be compact. 0.39. What is the ratio of the Number of enrolments of both sexes in Secondary in Croatia to that in Czech Republic?
Give a very brief answer. 0.03. What is the ratio of the Number of enrolments of both sexes of Secondary general in Croatia to that in Czech Republic?
Provide a short and direct response. 82.12. What is the ratio of the Number of enrolments of both sexes in Secondary vocational in Croatia to that in Czech Republic?
Offer a terse response. 0.02. What is the ratio of the Number of enrolments of both sexes in Primary in Croatia to that in Denmark?
Provide a short and direct response. 0.47. What is the ratio of the Number of enrolments of both sexes of Secondary in Croatia to that in Denmark?
Your response must be concise. 0.06. What is the ratio of the Number of enrolments of both sexes of Secondary general in Croatia to that in Denmark?
Offer a terse response. 0.77. What is the ratio of the Number of enrolments of both sexes of Secondary vocational in Croatia to that in Denmark?
Make the answer very short. 0. What is the ratio of the Number of enrolments of both sexes of Primary in Croatia to that in Djibouti?
Ensure brevity in your answer.  3.87. What is the ratio of the Number of enrolments of both sexes of Secondary in Croatia to that in Djibouti?
Provide a short and direct response. 1.18. What is the ratio of the Number of enrolments of both sexes of Secondary general in Croatia to that in Djibouti?
Your answer should be compact. 0.73. What is the ratio of the Number of enrolments of both sexes in Secondary vocational in Croatia to that in Djibouti?
Offer a terse response. 0.21. What is the ratio of the Number of enrolments of both sexes of Primary in Cuba to that in Cyprus?
Make the answer very short. 14.61. What is the ratio of the Number of enrolments of both sexes of Secondary in Cuba to that in Cyprus?
Offer a terse response. 0.01. What is the ratio of the Number of enrolments of both sexes of Secondary general in Cuba to that in Cyprus?
Your answer should be very brief. 12.21. What is the ratio of the Number of enrolments of both sexes in Secondary vocational in Cuba to that in Cyprus?
Your response must be concise. 0.18. What is the ratio of the Number of enrolments of both sexes of Primary in Cuba to that in Czech Republic?
Ensure brevity in your answer.  1.78. What is the ratio of the Number of enrolments of both sexes in Secondary in Cuba to that in Czech Republic?
Your answer should be very brief. 0.01. What is the ratio of the Number of enrolments of both sexes in Secondary general in Cuba to that in Czech Republic?
Make the answer very short. 47.05. What is the ratio of the Number of enrolments of both sexes in Secondary vocational in Cuba to that in Czech Republic?
Your response must be concise. 0.16. What is the ratio of the Number of enrolments of both sexes in Primary in Cuba to that in Denmark?
Provide a short and direct response. 2.16. What is the ratio of the Number of enrolments of both sexes of Secondary in Cuba to that in Denmark?
Give a very brief answer. 0.01. What is the ratio of the Number of enrolments of both sexes of Secondary general in Cuba to that in Denmark?
Provide a succinct answer. 0.44. What is the ratio of the Number of enrolments of both sexes in Secondary vocational in Cuba to that in Denmark?
Give a very brief answer. 0.01. What is the ratio of the Number of enrolments of both sexes of Primary in Cuba to that in Djibouti?
Ensure brevity in your answer.  17.67. What is the ratio of the Number of enrolments of both sexes in Secondary in Cuba to that in Djibouti?
Ensure brevity in your answer.  0.29. What is the ratio of the Number of enrolments of both sexes in Secondary general in Cuba to that in Djibouti?
Offer a terse response. 0.42. What is the ratio of the Number of enrolments of both sexes in Secondary vocational in Cuba to that in Djibouti?
Keep it short and to the point. 2.18. What is the ratio of the Number of enrolments of both sexes in Primary in Cyprus to that in Czech Republic?
Your answer should be compact. 0.12. What is the ratio of the Number of enrolments of both sexes in Secondary in Cyprus to that in Czech Republic?
Your answer should be very brief. 0.77. What is the ratio of the Number of enrolments of both sexes in Secondary general in Cyprus to that in Czech Republic?
Provide a short and direct response. 3.85. What is the ratio of the Number of enrolments of both sexes in Secondary vocational in Cyprus to that in Czech Republic?
Make the answer very short. 0.86. What is the ratio of the Number of enrolments of both sexes in Primary in Cyprus to that in Denmark?
Your answer should be very brief. 0.15. What is the ratio of the Number of enrolments of both sexes of Secondary in Cyprus to that in Denmark?
Keep it short and to the point. 1.54. What is the ratio of the Number of enrolments of both sexes in Secondary general in Cyprus to that in Denmark?
Offer a terse response. 0.04. What is the ratio of the Number of enrolments of both sexes of Secondary vocational in Cyprus to that in Denmark?
Your answer should be compact. 0.07. What is the ratio of the Number of enrolments of both sexes in Primary in Cyprus to that in Djibouti?
Your response must be concise. 1.21. What is the ratio of the Number of enrolments of both sexes in Secondary in Cyprus to that in Djibouti?
Offer a very short reply. 31.65. What is the ratio of the Number of enrolments of both sexes of Secondary general in Cyprus to that in Djibouti?
Make the answer very short. 0.03. What is the ratio of the Number of enrolments of both sexes of Secondary vocational in Cyprus to that in Djibouti?
Your answer should be compact. 12.12. What is the ratio of the Number of enrolments of both sexes in Primary in Czech Republic to that in Denmark?
Make the answer very short. 1.21. What is the ratio of the Number of enrolments of both sexes in Secondary in Czech Republic to that in Denmark?
Ensure brevity in your answer.  2.01. What is the ratio of the Number of enrolments of both sexes of Secondary general in Czech Republic to that in Denmark?
Keep it short and to the point. 0.01. What is the ratio of the Number of enrolments of both sexes in Secondary vocational in Czech Republic to that in Denmark?
Offer a very short reply. 0.08. What is the ratio of the Number of enrolments of both sexes in Primary in Czech Republic to that in Djibouti?
Make the answer very short. 9.93. What is the ratio of the Number of enrolments of both sexes of Secondary in Czech Republic to that in Djibouti?
Your answer should be compact. 41.23. What is the ratio of the Number of enrolments of both sexes in Secondary general in Czech Republic to that in Djibouti?
Ensure brevity in your answer.  0.01. What is the ratio of the Number of enrolments of both sexes in Secondary vocational in Czech Republic to that in Djibouti?
Give a very brief answer. 14.03. What is the ratio of the Number of enrolments of both sexes of Primary in Denmark to that in Djibouti?
Your answer should be compact. 8.18. What is the ratio of the Number of enrolments of both sexes of Secondary in Denmark to that in Djibouti?
Provide a short and direct response. 20.52. What is the ratio of the Number of enrolments of both sexes of Secondary general in Denmark to that in Djibouti?
Your answer should be very brief. 0.94. What is the ratio of the Number of enrolments of both sexes in Secondary vocational in Denmark to that in Djibouti?
Offer a terse response. 181.7. What is the difference between the highest and the second highest Number of enrolments of both sexes of Primary?
Offer a terse response. 3.92e+05. What is the difference between the highest and the second highest Number of enrolments of both sexes of Secondary?
Offer a very short reply. 2.45e+05. What is the difference between the highest and the second highest Number of enrolments of both sexes of Secondary general?
Keep it short and to the point. 4.68e+04. What is the difference between the highest and the second highest Number of enrolments of both sexes in Secondary vocational?
Ensure brevity in your answer.  1.47e+06. What is the difference between the highest and the lowest Number of enrolments of both sexes of Primary?
Your response must be concise. 8.44e+05. What is the difference between the highest and the lowest Number of enrolments of both sexes in Secondary?
Give a very brief answer. 1.05e+06. What is the difference between the highest and the lowest Number of enrolments of both sexes in Secondary general?
Provide a short and direct response. 8.08e+05. What is the difference between the highest and the lowest Number of enrolments of both sexes in Secondary vocational?
Your answer should be very brief. 1.59e+06. 